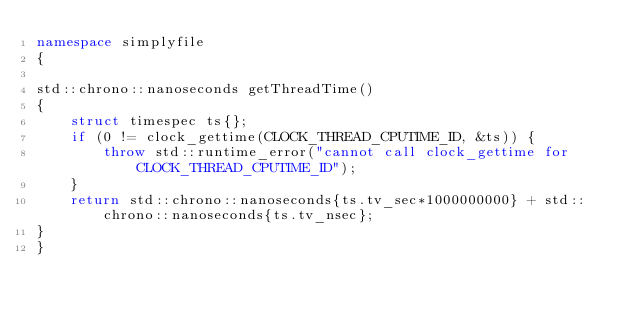Convert code to text. <code><loc_0><loc_0><loc_500><loc_500><_C++_>namespace simplyfile
{

std::chrono::nanoseconds getThreadTime()
{
	struct timespec ts{};
	if (0 != clock_gettime(CLOCK_THREAD_CPUTIME_ID, &ts)) {
		throw std::runtime_error("cannot call clock_gettime for CLOCK_THREAD_CPUTIME_ID");
	}
	return std::chrono::nanoseconds{ts.tv_sec*1000000000} + std::chrono::nanoseconds{ts.tv_nsec};
}
}
</code> 